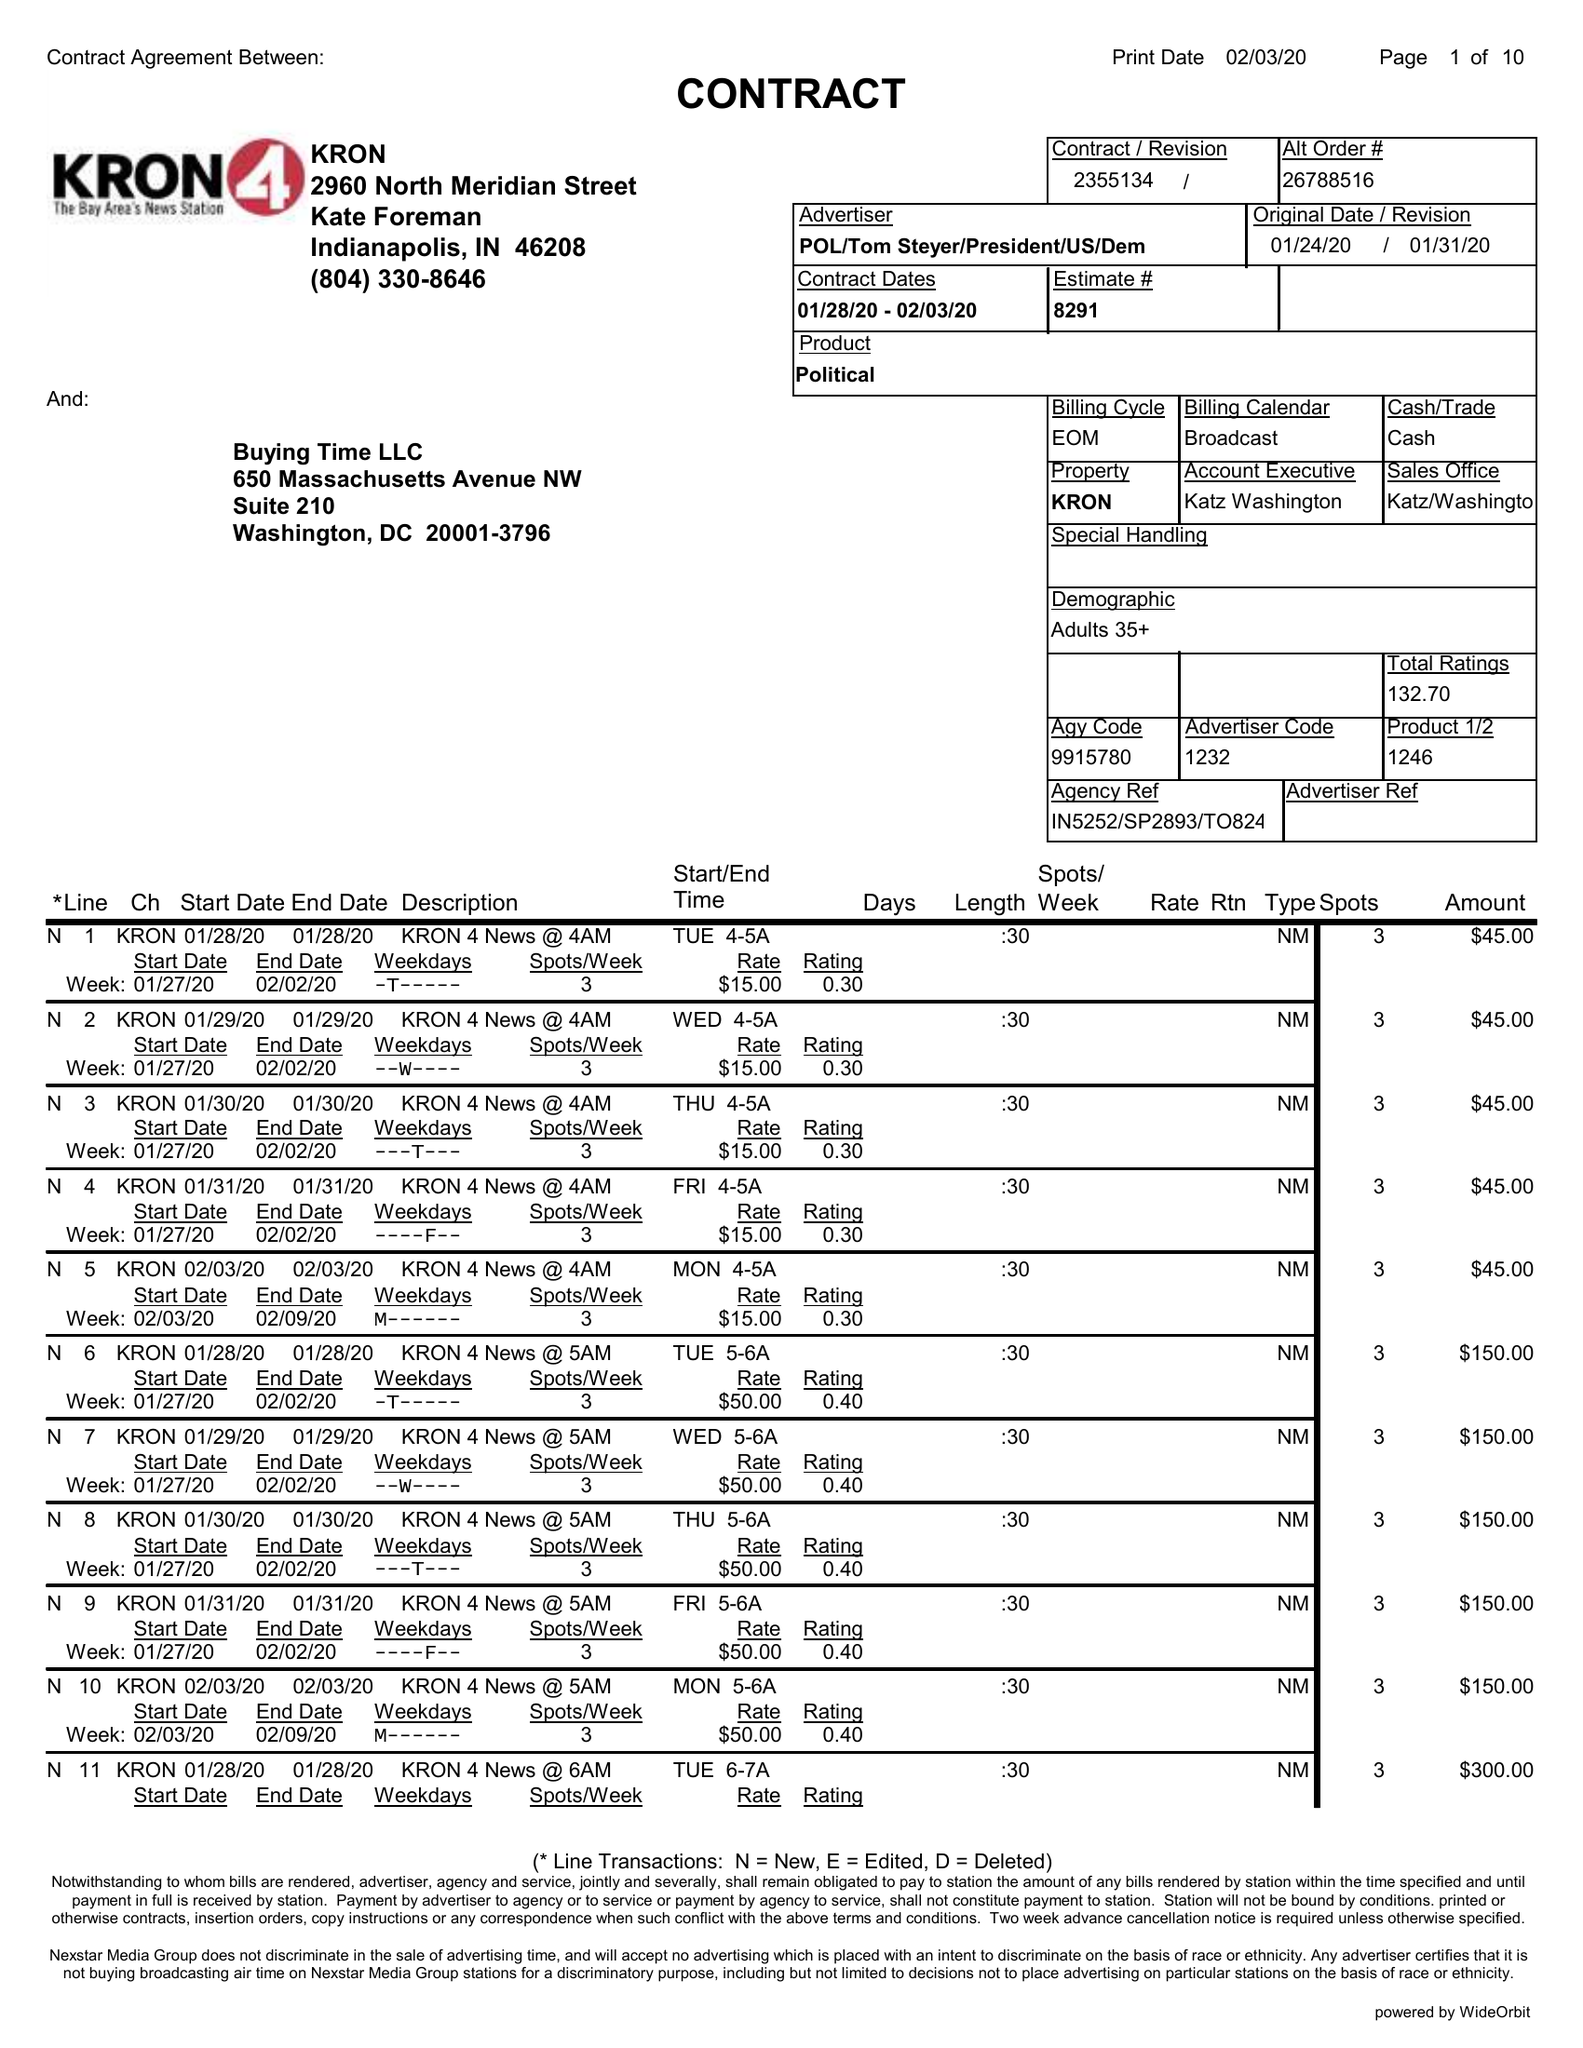What is the value for the contract_num?
Answer the question using a single word or phrase. 2355134 